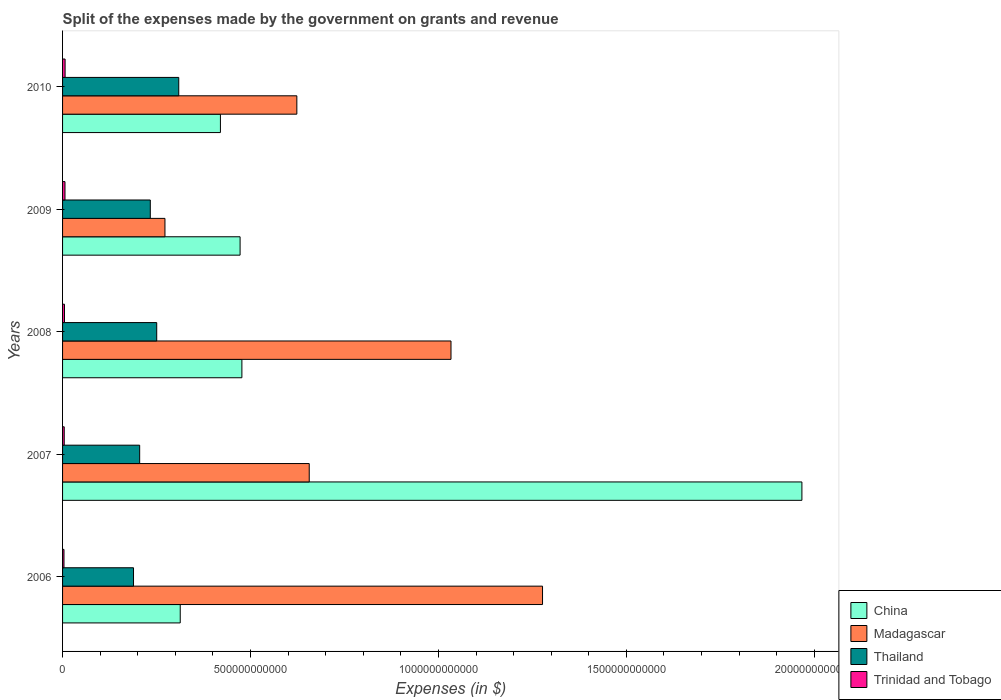How many different coloured bars are there?
Your response must be concise. 4. How many groups of bars are there?
Offer a terse response. 5. Are the number of bars per tick equal to the number of legend labels?
Provide a short and direct response. Yes. How many bars are there on the 1st tick from the top?
Keep it short and to the point. 4. What is the expenses made by the government on grants and revenue in Trinidad and Tobago in 2008?
Give a very brief answer. 5.11e+09. Across all years, what is the maximum expenses made by the government on grants and revenue in Madagascar?
Your answer should be very brief. 1.28e+12. Across all years, what is the minimum expenses made by the government on grants and revenue in Thailand?
Your answer should be very brief. 1.89e+11. What is the total expenses made by the government on grants and revenue in Madagascar in the graph?
Provide a succinct answer. 3.86e+12. What is the difference between the expenses made by the government on grants and revenue in Trinidad and Tobago in 2007 and that in 2010?
Provide a short and direct response. -2.32e+09. What is the difference between the expenses made by the government on grants and revenue in Trinidad and Tobago in 2010 and the expenses made by the government on grants and revenue in Madagascar in 2009?
Provide a succinct answer. -2.66e+11. What is the average expenses made by the government on grants and revenue in Trinidad and Tobago per year?
Offer a terse response. 5.30e+09. In the year 2010, what is the difference between the expenses made by the government on grants and revenue in China and expenses made by the government on grants and revenue in Thailand?
Provide a short and direct response. 1.11e+11. What is the ratio of the expenses made by the government on grants and revenue in Trinidad and Tobago in 2006 to that in 2008?
Give a very brief answer. 0.74. What is the difference between the highest and the second highest expenses made by the government on grants and revenue in Madagascar?
Provide a succinct answer. 2.44e+11. What is the difference between the highest and the lowest expenses made by the government on grants and revenue in Madagascar?
Provide a succinct answer. 1.00e+12. What does the 3rd bar from the top in 2010 represents?
Provide a short and direct response. Madagascar. What does the 4th bar from the bottom in 2008 represents?
Your answer should be compact. Trinidad and Tobago. Are all the bars in the graph horizontal?
Offer a very short reply. Yes. How many years are there in the graph?
Keep it short and to the point. 5. What is the difference between two consecutive major ticks on the X-axis?
Provide a succinct answer. 5.00e+11. Are the values on the major ticks of X-axis written in scientific E-notation?
Provide a succinct answer. No. Does the graph contain grids?
Your response must be concise. No. What is the title of the graph?
Provide a short and direct response. Split of the expenses made by the government on grants and revenue. Does "Tuvalu" appear as one of the legend labels in the graph?
Give a very brief answer. No. What is the label or title of the X-axis?
Keep it short and to the point. Expenses (in $). What is the Expenses (in $) in China in 2006?
Provide a succinct answer. 3.13e+11. What is the Expenses (in $) in Madagascar in 2006?
Offer a very short reply. 1.28e+12. What is the Expenses (in $) of Thailand in 2006?
Make the answer very short. 1.89e+11. What is the Expenses (in $) in Trinidad and Tobago in 2006?
Provide a succinct answer. 3.79e+09. What is the Expenses (in $) of China in 2007?
Provide a short and direct response. 1.97e+12. What is the Expenses (in $) of Madagascar in 2007?
Offer a very short reply. 6.56e+11. What is the Expenses (in $) in Thailand in 2007?
Make the answer very short. 2.05e+11. What is the Expenses (in $) in Trinidad and Tobago in 2007?
Your answer should be compact. 4.42e+09. What is the Expenses (in $) of China in 2008?
Provide a short and direct response. 4.77e+11. What is the Expenses (in $) of Madagascar in 2008?
Offer a very short reply. 1.03e+12. What is the Expenses (in $) of Thailand in 2008?
Provide a short and direct response. 2.50e+11. What is the Expenses (in $) of Trinidad and Tobago in 2008?
Give a very brief answer. 5.11e+09. What is the Expenses (in $) of China in 2009?
Keep it short and to the point. 4.72e+11. What is the Expenses (in $) of Madagascar in 2009?
Offer a terse response. 2.72e+11. What is the Expenses (in $) in Thailand in 2009?
Provide a succinct answer. 2.33e+11. What is the Expenses (in $) of Trinidad and Tobago in 2009?
Offer a very short reply. 6.45e+09. What is the Expenses (in $) in China in 2010?
Your answer should be compact. 4.20e+11. What is the Expenses (in $) in Madagascar in 2010?
Provide a succinct answer. 6.23e+11. What is the Expenses (in $) of Thailand in 2010?
Your answer should be compact. 3.09e+11. What is the Expenses (in $) of Trinidad and Tobago in 2010?
Give a very brief answer. 6.74e+09. Across all years, what is the maximum Expenses (in $) of China?
Ensure brevity in your answer.  1.97e+12. Across all years, what is the maximum Expenses (in $) in Madagascar?
Your answer should be compact. 1.28e+12. Across all years, what is the maximum Expenses (in $) in Thailand?
Offer a very short reply. 3.09e+11. Across all years, what is the maximum Expenses (in $) of Trinidad and Tobago?
Your answer should be compact. 6.74e+09. Across all years, what is the minimum Expenses (in $) in China?
Your response must be concise. 3.13e+11. Across all years, what is the minimum Expenses (in $) of Madagascar?
Offer a terse response. 2.72e+11. Across all years, what is the minimum Expenses (in $) of Thailand?
Keep it short and to the point. 1.89e+11. Across all years, what is the minimum Expenses (in $) of Trinidad and Tobago?
Ensure brevity in your answer.  3.79e+09. What is the total Expenses (in $) of China in the graph?
Give a very brief answer. 3.65e+12. What is the total Expenses (in $) in Madagascar in the graph?
Give a very brief answer. 3.86e+12. What is the total Expenses (in $) of Thailand in the graph?
Ensure brevity in your answer.  1.19e+12. What is the total Expenses (in $) in Trinidad and Tobago in the graph?
Your answer should be very brief. 2.65e+1. What is the difference between the Expenses (in $) in China in 2006 and that in 2007?
Make the answer very short. -1.65e+12. What is the difference between the Expenses (in $) of Madagascar in 2006 and that in 2007?
Your answer should be compact. 6.21e+11. What is the difference between the Expenses (in $) of Thailand in 2006 and that in 2007?
Provide a succinct answer. -1.64e+1. What is the difference between the Expenses (in $) of Trinidad and Tobago in 2006 and that in 2007?
Make the answer very short. -6.34e+08. What is the difference between the Expenses (in $) of China in 2006 and that in 2008?
Your answer should be compact. -1.64e+11. What is the difference between the Expenses (in $) of Madagascar in 2006 and that in 2008?
Offer a terse response. 2.44e+11. What is the difference between the Expenses (in $) of Thailand in 2006 and that in 2008?
Provide a succinct answer. -6.17e+1. What is the difference between the Expenses (in $) in Trinidad and Tobago in 2006 and that in 2008?
Keep it short and to the point. -1.32e+09. What is the difference between the Expenses (in $) of China in 2006 and that in 2009?
Your answer should be compact. -1.59e+11. What is the difference between the Expenses (in $) in Madagascar in 2006 and that in 2009?
Your answer should be very brief. 1.00e+12. What is the difference between the Expenses (in $) of Thailand in 2006 and that in 2009?
Your answer should be very brief. -4.47e+1. What is the difference between the Expenses (in $) of Trinidad and Tobago in 2006 and that in 2009?
Your response must be concise. -2.66e+09. What is the difference between the Expenses (in $) of China in 2006 and that in 2010?
Provide a short and direct response. -1.07e+11. What is the difference between the Expenses (in $) in Madagascar in 2006 and that in 2010?
Your answer should be compact. 6.54e+11. What is the difference between the Expenses (in $) in Thailand in 2006 and that in 2010?
Offer a very short reply. -1.20e+11. What is the difference between the Expenses (in $) of Trinidad and Tobago in 2006 and that in 2010?
Offer a very short reply. -2.95e+09. What is the difference between the Expenses (in $) of China in 2007 and that in 2008?
Provide a short and direct response. 1.49e+12. What is the difference between the Expenses (in $) of Madagascar in 2007 and that in 2008?
Offer a very short reply. -3.77e+11. What is the difference between the Expenses (in $) in Thailand in 2007 and that in 2008?
Make the answer very short. -4.54e+1. What is the difference between the Expenses (in $) in Trinidad and Tobago in 2007 and that in 2008?
Your response must be concise. -6.86e+08. What is the difference between the Expenses (in $) in China in 2007 and that in 2009?
Ensure brevity in your answer.  1.49e+12. What is the difference between the Expenses (in $) in Madagascar in 2007 and that in 2009?
Your response must be concise. 3.84e+11. What is the difference between the Expenses (in $) of Thailand in 2007 and that in 2009?
Provide a succinct answer. -2.83e+1. What is the difference between the Expenses (in $) of Trinidad and Tobago in 2007 and that in 2009?
Keep it short and to the point. -2.03e+09. What is the difference between the Expenses (in $) in China in 2007 and that in 2010?
Offer a very short reply. 1.55e+12. What is the difference between the Expenses (in $) of Madagascar in 2007 and that in 2010?
Provide a short and direct response. 3.30e+1. What is the difference between the Expenses (in $) in Thailand in 2007 and that in 2010?
Ensure brevity in your answer.  -1.04e+11. What is the difference between the Expenses (in $) of Trinidad and Tobago in 2007 and that in 2010?
Your answer should be very brief. -2.32e+09. What is the difference between the Expenses (in $) in China in 2008 and that in 2009?
Your answer should be very brief. 4.79e+09. What is the difference between the Expenses (in $) in Madagascar in 2008 and that in 2009?
Give a very brief answer. 7.61e+11. What is the difference between the Expenses (in $) in Thailand in 2008 and that in 2009?
Give a very brief answer. 1.71e+1. What is the difference between the Expenses (in $) in Trinidad and Tobago in 2008 and that in 2009?
Offer a terse response. -1.34e+09. What is the difference between the Expenses (in $) in China in 2008 and that in 2010?
Keep it short and to the point. 5.71e+1. What is the difference between the Expenses (in $) in Madagascar in 2008 and that in 2010?
Your answer should be very brief. 4.10e+11. What is the difference between the Expenses (in $) in Thailand in 2008 and that in 2010?
Make the answer very short. -5.86e+1. What is the difference between the Expenses (in $) in Trinidad and Tobago in 2008 and that in 2010?
Your answer should be compact. -1.63e+09. What is the difference between the Expenses (in $) of China in 2009 and that in 2010?
Make the answer very short. 5.23e+1. What is the difference between the Expenses (in $) of Madagascar in 2009 and that in 2010?
Provide a succinct answer. -3.51e+11. What is the difference between the Expenses (in $) of Thailand in 2009 and that in 2010?
Keep it short and to the point. -7.57e+1. What is the difference between the Expenses (in $) in Trinidad and Tobago in 2009 and that in 2010?
Your answer should be very brief. -2.85e+08. What is the difference between the Expenses (in $) in China in 2006 and the Expenses (in $) in Madagascar in 2007?
Provide a short and direct response. -3.43e+11. What is the difference between the Expenses (in $) of China in 2006 and the Expenses (in $) of Thailand in 2007?
Provide a short and direct response. 1.08e+11. What is the difference between the Expenses (in $) in China in 2006 and the Expenses (in $) in Trinidad and Tobago in 2007?
Give a very brief answer. 3.09e+11. What is the difference between the Expenses (in $) in Madagascar in 2006 and the Expenses (in $) in Thailand in 2007?
Your answer should be very brief. 1.07e+12. What is the difference between the Expenses (in $) of Madagascar in 2006 and the Expenses (in $) of Trinidad and Tobago in 2007?
Give a very brief answer. 1.27e+12. What is the difference between the Expenses (in $) of Thailand in 2006 and the Expenses (in $) of Trinidad and Tobago in 2007?
Your response must be concise. 1.84e+11. What is the difference between the Expenses (in $) in China in 2006 and the Expenses (in $) in Madagascar in 2008?
Make the answer very short. -7.20e+11. What is the difference between the Expenses (in $) of China in 2006 and the Expenses (in $) of Thailand in 2008?
Your answer should be very brief. 6.26e+1. What is the difference between the Expenses (in $) of China in 2006 and the Expenses (in $) of Trinidad and Tobago in 2008?
Your answer should be compact. 3.08e+11. What is the difference between the Expenses (in $) of Madagascar in 2006 and the Expenses (in $) of Thailand in 2008?
Ensure brevity in your answer.  1.03e+12. What is the difference between the Expenses (in $) in Madagascar in 2006 and the Expenses (in $) in Trinidad and Tobago in 2008?
Your answer should be very brief. 1.27e+12. What is the difference between the Expenses (in $) of Thailand in 2006 and the Expenses (in $) of Trinidad and Tobago in 2008?
Ensure brevity in your answer.  1.84e+11. What is the difference between the Expenses (in $) of China in 2006 and the Expenses (in $) of Madagascar in 2009?
Offer a terse response. 4.07e+1. What is the difference between the Expenses (in $) of China in 2006 and the Expenses (in $) of Thailand in 2009?
Your answer should be compact. 7.97e+1. What is the difference between the Expenses (in $) in China in 2006 and the Expenses (in $) in Trinidad and Tobago in 2009?
Your answer should be very brief. 3.07e+11. What is the difference between the Expenses (in $) in Madagascar in 2006 and the Expenses (in $) in Thailand in 2009?
Your answer should be compact. 1.04e+12. What is the difference between the Expenses (in $) in Madagascar in 2006 and the Expenses (in $) in Trinidad and Tobago in 2009?
Ensure brevity in your answer.  1.27e+12. What is the difference between the Expenses (in $) of Thailand in 2006 and the Expenses (in $) of Trinidad and Tobago in 2009?
Ensure brevity in your answer.  1.82e+11. What is the difference between the Expenses (in $) of China in 2006 and the Expenses (in $) of Madagascar in 2010?
Offer a very short reply. -3.10e+11. What is the difference between the Expenses (in $) in China in 2006 and the Expenses (in $) in Thailand in 2010?
Make the answer very short. 3.98e+09. What is the difference between the Expenses (in $) of China in 2006 and the Expenses (in $) of Trinidad and Tobago in 2010?
Give a very brief answer. 3.06e+11. What is the difference between the Expenses (in $) in Madagascar in 2006 and the Expenses (in $) in Thailand in 2010?
Your answer should be compact. 9.68e+11. What is the difference between the Expenses (in $) of Madagascar in 2006 and the Expenses (in $) of Trinidad and Tobago in 2010?
Your response must be concise. 1.27e+12. What is the difference between the Expenses (in $) of Thailand in 2006 and the Expenses (in $) of Trinidad and Tobago in 2010?
Give a very brief answer. 1.82e+11. What is the difference between the Expenses (in $) of China in 2007 and the Expenses (in $) of Madagascar in 2008?
Your answer should be compact. 9.34e+11. What is the difference between the Expenses (in $) of China in 2007 and the Expenses (in $) of Thailand in 2008?
Give a very brief answer. 1.72e+12. What is the difference between the Expenses (in $) in China in 2007 and the Expenses (in $) in Trinidad and Tobago in 2008?
Provide a succinct answer. 1.96e+12. What is the difference between the Expenses (in $) of Madagascar in 2007 and the Expenses (in $) of Thailand in 2008?
Ensure brevity in your answer.  4.06e+11. What is the difference between the Expenses (in $) of Madagascar in 2007 and the Expenses (in $) of Trinidad and Tobago in 2008?
Provide a succinct answer. 6.51e+11. What is the difference between the Expenses (in $) in Thailand in 2007 and the Expenses (in $) in Trinidad and Tobago in 2008?
Make the answer very short. 2.00e+11. What is the difference between the Expenses (in $) in China in 2007 and the Expenses (in $) in Madagascar in 2009?
Keep it short and to the point. 1.69e+12. What is the difference between the Expenses (in $) of China in 2007 and the Expenses (in $) of Thailand in 2009?
Provide a succinct answer. 1.73e+12. What is the difference between the Expenses (in $) in China in 2007 and the Expenses (in $) in Trinidad and Tobago in 2009?
Offer a very short reply. 1.96e+12. What is the difference between the Expenses (in $) in Madagascar in 2007 and the Expenses (in $) in Thailand in 2009?
Offer a terse response. 4.23e+11. What is the difference between the Expenses (in $) in Madagascar in 2007 and the Expenses (in $) in Trinidad and Tobago in 2009?
Keep it short and to the point. 6.50e+11. What is the difference between the Expenses (in $) in Thailand in 2007 and the Expenses (in $) in Trinidad and Tobago in 2009?
Ensure brevity in your answer.  1.99e+11. What is the difference between the Expenses (in $) in China in 2007 and the Expenses (in $) in Madagascar in 2010?
Provide a short and direct response. 1.34e+12. What is the difference between the Expenses (in $) in China in 2007 and the Expenses (in $) in Thailand in 2010?
Your response must be concise. 1.66e+12. What is the difference between the Expenses (in $) of China in 2007 and the Expenses (in $) of Trinidad and Tobago in 2010?
Ensure brevity in your answer.  1.96e+12. What is the difference between the Expenses (in $) in Madagascar in 2007 and the Expenses (in $) in Thailand in 2010?
Provide a succinct answer. 3.47e+11. What is the difference between the Expenses (in $) of Madagascar in 2007 and the Expenses (in $) of Trinidad and Tobago in 2010?
Make the answer very short. 6.49e+11. What is the difference between the Expenses (in $) in Thailand in 2007 and the Expenses (in $) in Trinidad and Tobago in 2010?
Make the answer very short. 1.98e+11. What is the difference between the Expenses (in $) in China in 2008 and the Expenses (in $) in Madagascar in 2009?
Provide a short and direct response. 2.05e+11. What is the difference between the Expenses (in $) in China in 2008 and the Expenses (in $) in Thailand in 2009?
Provide a succinct answer. 2.44e+11. What is the difference between the Expenses (in $) of China in 2008 and the Expenses (in $) of Trinidad and Tobago in 2009?
Make the answer very short. 4.71e+11. What is the difference between the Expenses (in $) in Madagascar in 2008 and the Expenses (in $) in Thailand in 2009?
Your answer should be compact. 8.00e+11. What is the difference between the Expenses (in $) of Madagascar in 2008 and the Expenses (in $) of Trinidad and Tobago in 2009?
Your answer should be very brief. 1.03e+12. What is the difference between the Expenses (in $) in Thailand in 2008 and the Expenses (in $) in Trinidad and Tobago in 2009?
Your response must be concise. 2.44e+11. What is the difference between the Expenses (in $) of China in 2008 and the Expenses (in $) of Madagascar in 2010?
Provide a short and direct response. -1.46e+11. What is the difference between the Expenses (in $) of China in 2008 and the Expenses (in $) of Thailand in 2010?
Your answer should be compact. 1.68e+11. What is the difference between the Expenses (in $) of China in 2008 and the Expenses (in $) of Trinidad and Tobago in 2010?
Keep it short and to the point. 4.70e+11. What is the difference between the Expenses (in $) of Madagascar in 2008 and the Expenses (in $) of Thailand in 2010?
Offer a terse response. 7.24e+11. What is the difference between the Expenses (in $) in Madagascar in 2008 and the Expenses (in $) in Trinidad and Tobago in 2010?
Your answer should be compact. 1.03e+12. What is the difference between the Expenses (in $) of Thailand in 2008 and the Expenses (in $) of Trinidad and Tobago in 2010?
Your response must be concise. 2.44e+11. What is the difference between the Expenses (in $) in China in 2009 and the Expenses (in $) in Madagascar in 2010?
Your answer should be compact. -1.51e+11. What is the difference between the Expenses (in $) of China in 2009 and the Expenses (in $) of Thailand in 2010?
Provide a succinct answer. 1.63e+11. What is the difference between the Expenses (in $) of China in 2009 and the Expenses (in $) of Trinidad and Tobago in 2010?
Give a very brief answer. 4.66e+11. What is the difference between the Expenses (in $) of Madagascar in 2009 and the Expenses (in $) of Thailand in 2010?
Keep it short and to the point. -3.67e+1. What is the difference between the Expenses (in $) in Madagascar in 2009 and the Expenses (in $) in Trinidad and Tobago in 2010?
Keep it short and to the point. 2.66e+11. What is the difference between the Expenses (in $) of Thailand in 2009 and the Expenses (in $) of Trinidad and Tobago in 2010?
Offer a very short reply. 2.27e+11. What is the average Expenses (in $) in China per year?
Provide a succinct answer. 7.30e+11. What is the average Expenses (in $) of Madagascar per year?
Your answer should be very brief. 7.72e+11. What is the average Expenses (in $) of Thailand per year?
Provide a succinct answer. 2.37e+11. What is the average Expenses (in $) in Trinidad and Tobago per year?
Keep it short and to the point. 5.30e+09. In the year 2006, what is the difference between the Expenses (in $) in China and Expenses (in $) in Madagascar?
Offer a terse response. -9.64e+11. In the year 2006, what is the difference between the Expenses (in $) of China and Expenses (in $) of Thailand?
Keep it short and to the point. 1.24e+11. In the year 2006, what is the difference between the Expenses (in $) of China and Expenses (in $) of Trinidad and Tobago?
Your response must be concise. 3.09e+11. In the year 2006, what is the difference between the Expenses (in $) in Madagascar and Expenses (in $) in Thailand?
Offer a very short reply. 1.09e+12. In the year 2006, what is the difference between the Expenses (in $) in Madagascar and Expenses (in $) in Trinidad and Tobago?
Your answer should be compact. 1.27e+12. In the year 2006, what is the difference between the Expenses (in $) in Thailand and Expenses (in $) in Trinidad and Tobago?
Provide a succinct answer. 1.85e+11. In the year 2007, what is the difference between the Expenses (in $) of China and Expenses (in $) of Madagascar?
Give a very brief answer. 1.31e+12. In the year 2007, what is the difference between the Expenses (in $) of China and Expenses (in $) of Thailand?
Make the answer very short. 1.76e+12. In the year 2007, what is the difference between the Expenses (in $) in China and Expenses (in $) in Trinidad and Tobago?
Your response must be concise. 1.96e+12. In the year 2007, what is the difference between the Expenses (in $) of Madagascar and Expenses (in $) of Thailand?
Your answer should be compact. 4.51e+11. In the year 2007, what is the difference between the Expenses (in $) of Madagascar and Expenses (in $) of Trinidad and Tobago?
Make the answer very short. 6.52e+11. In the year 2007, what is the difference between the Expenses (in $) in Thailand and Expenses (in $) in Trinidad and Tobago?
Offer a very short reply. 2.01e+11. In the year 2008, what is the difference between the Expenses (in $) in China and Expenses (in $) in Madagascar?
Provide a short and direct response. -5.56e+11. In the year 2008, what is the difference between the Expenses (in $) of China and Expenses (in $) of Thailand?
Your answer should be very brief. 2.27e+11. In the year 2008, what is the difference between the Expenses (in $) in China and Expenses (in $) in Trinidad and Tobago?
Provide a succinct answer. 4.72e+11. In the year 2008, what is the difference between the Expenses (in $) of Madagascar and Expenses (in $) of Thailand?
Provide a succinct answer. 7.83e+11. In the year 2008, what is the difference between the Expenses (in $) in Madagascar and Expenses (in $) in Trinidad and Tobago?
Provide a succinct answer. 1.03e+12. In the year 2008, what is the difference between the Expenses (in $) of Thailand and Expenses (in $) of Trinidad and Tobago?
Give a very brief answer. 2.45e+11. In the year 2009, what is the difference between the Expenses (in $) in China and Expenses (in $) in Madagascar?
Provide a succinct answer. 2.00e+11. In the year 2009, what is the difference between the Expenses (in $) of China and Expenses (in $) of Thailand?
Offer a terse response. 2.39e+11. In the year 2009, what is the difference between the Expenses (in $) of China and Expenses (in $) of Trinidad and Tobago?
Your response must be concise. 4.66e+11. In the year 2009, what is the difference between the Expenses (in $) in Madagascar and Expenses (in $) in Thailand?
Your answer should be compact. 3.90e+1. In the year 2009, what is the difference between the Expenses (in $) in Madagascar and Expenses (in $) in Trinidad and Tobago?
Your response must be concise. 2.66e+11. In the year 2009, what is the difference between the Expenses (in $) of Thailand and Expenses (in $) of Trinidad and Tobago?
Give a very brief answer. 2.27e+11. In the year 2010, what is the difference between the Expenses (in $) in China and Expenses (in $) in Madagascar?
Make the answer very short. -2.03e+11. In the year 2010, what is the difference between the Expenses (in $) of China and Expenses (in $) of Thailand?
Your answer should be compact. 1.11e+11. In the year 2010, what is the difference between the Expenses (in $) of China and Expenses (in $) of Trinidad and Tobago?
Keep it short and to the point. 4.13e+11. In the year 2010, what is the difference between the Expenses (in $) in Madagascar and Expenses (in $) in Thailand?
Make the answer very short. 3.14e+11. In the year 2010, what is the difference between the Expenses (in $) in Madagascar and Expenses (in $) in Trinidad and Tobago?
Your answer should be very brief. 6.17e+11. In the year 2010, what is the difference between the Expenses (in $) of Thailand and Expenses (in $) of Trinidad and Tobago?
Your answer should be compact. 3.02e+11. What is the ratio of the Expenses (in $) in China in 2006 to that in 2007?
Give a very brief answer. 0.16. What is the ratio of the Expenses (in $) in Madagascar in 2006 to that in 2007?
Your response must be concise. 1.95. What is the ratio of the Expenses (in $) in Thailand in 2006 to that in 2007?
Make the answer very short. 0.92. What is the ratio of the Expenses (in $) in Trinidad and Tobago in 2006 to that in 2007?
Make the answer very short. 0.86. What is the ratio of the Expenses (in $) of China in 2006 to that in 2008?
Ensure brevity in your answer.  0.66. What is the ratio of the Expenses (in $) in Madagascar in 2006 to that in 2008?
Provide a succinct answer. 1.24. What is the ratio of the Expenses (in $) in Thailand in 2006 to that in 2008?
Your answer should be compact. 0.75. What is the ratio of the Expenses (in $) in Trinidad and Tobago in 2006 to that in 2008?
Provide a succinct answer. 0.74. What is the ratio of the Expenses (in $) of China in 2006 to that in 2009?
Your answer should be compact. 0.66. What is the ratio of the Expenses (in $) in Madagascar in 2006 to that in 2009?
Give a very brief answer. 4.69. What is the ratio of the Expenses (in $) in Thailand in 2006 to that in 2009?
Offer a very short reply. 0.81. What is the ratio of the Expenses (in $) in Trinidad and Tobago in 2006 to that in 2009?
Offer a very short reply. 0.59. What is the ratio of the Expenses (in $) of China in 2006 to that in 2010?
Your response must be concise. 0.75. What is the ratio of the Expenses (in $) of Madagascar in 2006 to that in 2010?
Ensure brevity in your answer.  2.05. What is the ratio of the Expenses (in $) of Thailand in 2006 to that in 2010?
Ensure brevity in your answer.  0.61. What is the ratio of the Expenses (in $) in Trinidad and Tobago in 2006 to that in 2010?
Provide a short and direct response. 0.56. What is the ratio of the Expenses (in $) of China in 2007 to that in 2008?
Ensure brevity in your answer.  4.12. What is the ratio of the Expenses (in $) of Madagascar in 2007 to that in 2008?
Offer a terse response. 0.64. What is the ratio of the Expenses (in $) in Thailand in 2007 to that in 2008?
Your answer should be very brief. 0.82. What is the ratio of the Expenses (in $) in Trinidad and Tobago in 2007 to that in 2008?
Your response must be concise. 0.87. What is the ratio of the Expenses (in $) of China in 2007 to that in 2009?
Ensure brevity in your answer.  4.16. What is the ratio of the Expenses (in $) of Madagascar in 2007 to that in 2009?
Provide a succinct answer. 2.41. What is the ratio of the Expenses (in $) in Thailand in 2007 to that in 2009?
Make the answer very short. 0.88. What is the ratio of the Expenses (in $) in Trinidad and Tobago in 2007 to that in 2009?
Provide a short and direct response. 0.69. What is the ratio of the Expenses (in $) in China in 2007 to that in 2010?
Provide a short and direct response. 4.68. What is the ratio of the Expenses (in $) in Madagascar in 2007 to that in 2010?
Ensure brevity in your answer.  1.05. What is the ratio of the Expenses (in $) in Thailand in 2007 to that in 2010?
Ensure brevity in your answer.  0.66. What is the ratio of the Expenses (in $) of Trinidad and Tobago in 2007 to that in 2010?
Provide a short and direct response. 0.66. What is the ratio of the Expenses (in $) in China in 2008 to that in 2009?
Your answer should be very brief. 1.01. What is the ratio of the Expenses (in $) in Madagascar in 2008 to that in 2009?
Your answer should be compact. 3.79. What is the ratio of the Expenses (in $) in Thailand in 2008 to that in 2009?
Provide a short and direct response. 1.07. What is the ratio of the Expenses (in $) in Trinidad and Tobago in 2008 to that in 2009?
Provide a short and direct response. 0.79. What is the ratio of the Expenses (in $) of China in 2008 to that in 2010?
Your response must be concise. 1.14. What is the ratio of the Expenses (in $) in Madagascar in 2008 to that in 2010?
Ensure brevity in your answer.  1.66. What is the ratio of the Expenses (in $) in Thailand in 2008 to that in 2010?
Your answer should be very brief. 0.81. What is the ratio of the Expenses (in $) of Trinidad and Tobago in 2008 to that in 2010?
Your response must be concise. 0.76. What is the ratio of the Expenses (in $) of China in 2009 to that in 2010?
Ensure brevity in your answer.  1.12. What is the ratio of the Expenses (in $) in Madagascar in 2009 to that in 2010?
Provide a short and direct response. 0.44. What is the ratio of the Expenses (in $) of Thailand in 2009 to that in 2010?
Your answer should be very brief. 0.76. What is the ratio of the Expenses (in $) in Trinidad and Tobago in 2009 to that in 2010?
Offer a terse response. 0.96. What is the difference between the highest and the second highest Expenses (in $) in China?
Your answer should be compact. 1.49e+12. What is the difference between the highest and the second highest Expenses (in $) of Madagascar?
Ensure brevity in your answer.  2.44e+11. What is the difference between the highest and the second highest Expenses (in $) of Thailand?
Offer a terse response. 5.86e+1. What is the difference between the highest and the second highest Expenses (in $) of Trinidad and Tobago?
Provide a short and direct response. 2.85e+08. What is the difference between the highest and the lowest Expenses (in $) of China?
Your answer should be very brief. 1.65e+12. What is the difference between the highest and the lowest Expenses (in $) in Madagascar?
Give a very brief answer. 1.00e+12. What is the difference between the highest and the lowest Expenses (in $) of Thailand?
Your answer should be very brief. 1.20e+11. What is the difference between the highest and the lowest Expenses (in $) of Trinidad and Tobago?
Your answer should be very brief. 2.95e+09. 